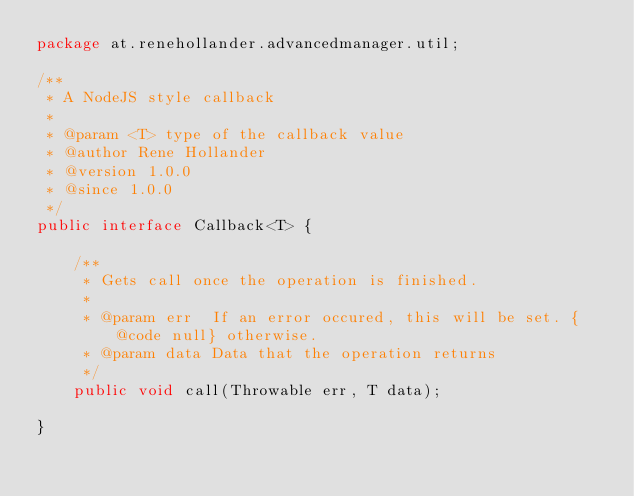<code> <loc_0><loc_0><loc_500><loc_500><_Java_>package at.renehollander.advancedmanager.util;

/**
 * A NodeJS style callback
 *
 * @param <T> type of the callback value
 * @author Rene Hollander
 * @version 1.0.0
 * @since 1.0.0
 */
public interface Callback<T> {

    /**
     * Gets call once the operation is finished.
     *
     * @param err  If an error occured, this will be set. {@code null} otherwise.
     * @param data Data that the operation returns
     */
    public void call(Throwable err, T data);

}
</code> 